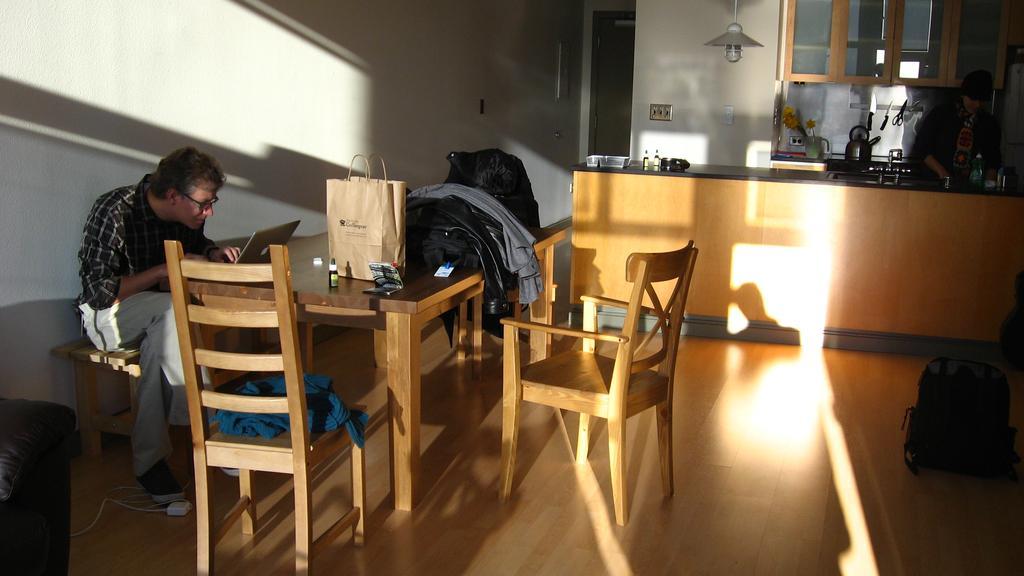Describe this image in one or two sentences. In this picture there is a man sitting on a bench, there is a table in front of him and his operating a laptop, there is a bag and couple of clothes and there are some empty chairs over here 